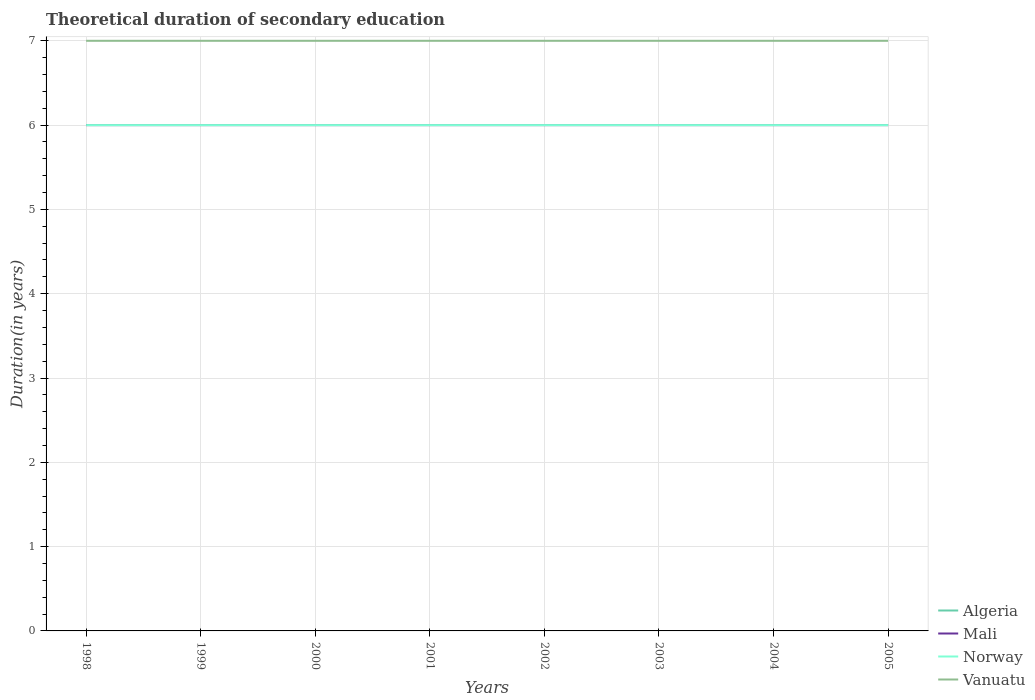Does the line corresponding to Vanuatu intersect with the line corresponding to Algeria?
Make the answer very short. No. Across all years, what is the maximum total theoretical duration of secondary education in Norway?
Provide a succinct answer. 6. In which year was the total theoretical duration of secondary education in Vanuatu maximum?
Provide a short and direct response. 1998. What is the total total theoretical duration of secondary education in Mali in the graph?
Offer a very short reply. 0. What is the difference between the highest and the second highest total theoretical duration of secondary education in Mali?
Your answer should be very brief. 0. How many years are there in the graph?
Make the answer very short. 8. Are the values on the major ticks of Y-axis written in scientific E-notation?
Your response must be concise. No. Does the graph contain grids?
Keep it short and to the point. Yes. Where does the legend appear in the graph?
Your response must be concise. Bottom right. How many legend labels are there?
Give a very brief answer. 4. How are the legend labels stacked?
Offer a very short reply. Vertical. What is the title of the graph?
Make the answer very short. Theoretical duration of secondary education. Does "Haiti" appear as one of the legend labels in the graph?
Provide a short and direct response. No. What is the label or title of the Y-axis?
Offer a terse response. Duration(in years). What is the Duration(in years) in Norway in 1998?
Offer a very short reply. 6. What is the Duration(in years) in Vanuatu in 1998?
Provide a succinct answer. 7. What is the Duration(in years) in Mali in 1999?
Your answer should be very brief. 6. What is the Duration(in years) in Norway in 1999?
Make the answer very short. 6. What is the Duration(in years) in Vanuatu in 1999?
Your answer should be very brief. 7. What is the Duration(in years) in Algeria in 2000?
Ensure brevity in your answer.  6. What is the Duration(in years) of Mali in 2000?
Your answer should be very brief. 6. What is the Duration(in years) of Vanuatu in 2000?
Provide a succinct answer. 7. What is the Duration(in years) in Mali in 2001?
Offer a very short reply. 6. What is the Duration(in years) of Norway in 2001?
Keep it short and to the point. 6. What is the Duration(in years) in Mali in 2002?
Make the answer very short. 6. What is the Duration(in years) in Algeria in 2003?
Provide a succinct answer. 6. What is the Duration(in years) in Norway in 2004?
Offer a very short reply. 6. What is the Duration(in years) in Algeria in 2005?
Keep it short and to the point. 6. What is the Duration(in years) in Vanuatu in 2005?
Your answer should be very brief. 7. Across all years, what is the maximum Duration(in years) of Vanuatu?
Provide a succinct answer. 7. Across all years, what is the minimum Duration(in years) of Norway?
Your answer should be very brief. 6. What is the total Duration(in years) in Mali in the graph?
Keep it short and to the point. 48. What is the total Duration(in years) in Norway in the graph?
Offer a very short reply. 48. What is the difference between the Duration(in years) of Algeria in 1998 and that in 1999?
Your answer should be compact. 0. What is the difference between the Duration(in years) in Mali in 1998 and that in 1999?
Provide a succinct answer. 0. What is the difference between the Duration(in years) in Norway in 1998 and that in 1999?
Provide a short and direct response. 0. What is the difference between the Duration(in years) of Vanuatu in 1998 and that in 1999?
Offer a terse response. 0. What is the difference between the Duration(in years) of Mali in 1998 and that in 2000?
Provide a succinct answer. 0. What is the difference between the Duration(in years) of Algeria in 1998 and that in 2001?
Ensure brevity in your answer.  0. What is the difference between the Duration(in years) in Mali in 1998 and that in 2002?
Offer a terse response. 0. What is the difference between the Duration(in years) of Vanuatu in 1998 and that in 2002?
Make the answer very short. 0. What is the difference between the Duration(in years) in Vanuatu in 1998 and that in 2003?
Keep it short and to the point. 0. What is the difference between the Duration(in years) in Algeria in 1998 and that in 2004?
Provide a short and direct response. 0. What is the difference between the Duration(in years) of Vanuatu in 1998 and that in 2004?
Provide a succinct answer. 0. What is the difference between the Duration(in years) of Algeria in 1998 and that in 2005?
Your response must be concise. 0. What is the difference between the Duration(in years) in Mali in 1998 and that in 2005?
Offer a very short reply. 0. What is the difference between the Duration(in years) in Vanuatu in 1998 and that in 2005?
Ensure brevity in your answer.  0. What is the difference between the Duration(in years) in Mali in 1999 and that in 2000?
Give a very brief answer. 0. What is the difference between the Duration(in years) of Norway in 1999 and that in 2000?
Your response must be concise. 0. What is the difference between the Duration(in years) of Algeria in 1999 and that in 2001?
Provide a succinct answer. 0. What is the difference between the Duration(in years) of Mali in 1999 and that in 2001?
Your answer should be compact. 0. What is the difference between the Duration(in years) in Vanuatu in 1999 and that in 2001?
Provide a succinct answer. 0. What is the difference between the Duration(in years) in Algeria in 1999 and that in 2002?
Provide a succinct answer. 0. What is the difference between the Duration(in years) in Norway in 1999 and that in 2002?
Keep it short and to the point. 0. What is the difference between the Duration(in years) of Vanuatu in 1999 and that in 2002?
Your answer should be compact. 0. What is the difference between the Duration(in years) in Algeria in 1999 and that in 2003?
Your response must be concise. 0. What is the difference between the Duration(in years) in Mali in 1999 and that in 2003?
Ensure brevity in your answer.  0. What is the difference between the Duration(in years) of Mali in 1999 and that in 2004?
Offer a very short reply. 0. What is the difference between the Duration(in years) of Norway in 1999 and that in 2004?
Provide a succinct answer. 0. What is the difference between the Duration(in years) of Vanuatu in 1999 and that in 2004?
Your answer should be compact. 0. What is the difference between the Duration(in years) in Norway in 1999 and that in 2005?
Give a very brief answer. 0. What is the difference between the Duration(in years) of Mali in 2000 and that in 2001?
Offer a terse response. 0. What is the difference between the Duration(in years) in Norway in 2000 and that in 2001?
Offer a very short reply. 0. What is the difference between the Duration(in years) of Vanuatu in 2000 and that in 2001?
Make the answer very short. 0. What is the difference between the Duration(in years) of Norway in 2000 and that in 2002?
Make the answer very short. 0. What is the difference between the Duration(in years) of Vanuatu in 2000 and that in 2002?
Offer a terse response. 0. What is the difference between the Duration(in years) of Mali in 2000 and that in 2004?
Offer a very short reply. 0. What is the difference between the Duration(in years) in Norway in 2000 and that in 2004?
Your response must be concise. 0. What is the difference between the Duration(in years) in Mali in 2001 and that in 2002?
Make the answer very short. 0. What is the difference between the Duration(in years) of Norway in 2001 and that in 2002?
Make the answer very short. 0. What is the difference between the Duration(in years) of Algeria in 2001 and that in 2004?
Your answer should be very brief. 0. What is the difference between the Duration(in years) of Mali in 2001 and that in 2004?
Make the answer very short. 0. What is the difference between the Duration(in years) in Norway in 2001 and that in 2004?
Make the answer very short. 0. What is the difference between the Duration(in years) of Norway in 2001 and that in 2005?
Your answer should be compact. 0. What is the difference between the Duration(in years) of Mali in 2002 and that in 2003?
Provide a short and direct response. 0. What is the difference between the Duration(in years) of Algeria in 2002 and that in 2004?
Offer a terse response. 0. What is the difference between the Duration(in years) of Mali in 2002 and that in 2004?
Your answer should be very brief. 0. What is the difference between the Duration(in years) of Vanuatu in 2002 and that in 2004?
Ensure brevity in your answer.  0. What is the difference between the Duration(in years) in Algeria in 2002 and that in 2005?
Your response must be concise. 0. What is the difference between the Duration(in years) in Vanuatu in 2002 and that in 2005?
Ensure brevity in your answer.  0. What is the difference between the Duration(in years) in Mali in 2003 and that in 2004?
Provide a succinct answer. 0. What is the difference between the Duration(in years) in Algeria in 2003 and that in 2005?
Provide a succinct answer. 0. What is the difference between the Duration(in years) of Mali in 2003 and that in 2005?
Your answer should be very brief. 0. What is the difference between the Duration(in years) in Vanuatu in 2003 and that in 2005?
Keep it short and to the point. 0. What is the difference between the Duration(in years) in Algeria in 2004 and that in 2005?
Your response must be concise. 0. What is the difference between the Duration(in years) in Norway in 2004 and that in 2005?
Your response must be concise. 0. What is the difference between the Duration(in years) in Vanuatu in 2004 and that in 2005?
Keep it short and to the point. 0. What is the difference between the Duration(in years) in Algeria in 1998 and the Duration(in years) in Norway in 1999?
Provide a short and direct response. 0. What is the difference between the Duration(in years) of Algeria in 1998 and the Duration(in years) of Norway in 2000?
Your response must be concise. 0. What is the difference between the Duration(in years) of Mali in 1998 and the Duration(in years) of Norway in 2000?
Offer a terse response. 0. What is the difference between the Duration(in years) of Mali in 1998 and the Duration(in years) of Vanuatu in 2000?
Make the answer very short. -1. What is the difference between the Duration(in years) of Norway in 1998 and the Duration(in years) of Vanuatu in 2000?
Give a very brief answer. -1. What is the difference between the Duration(in years) in Mali in 1998 and the Duration(in years) in Vanuatu in 2001?
Offer a very short reply. -1. What is the difference between the Duration(in years) in Algeria in 1998 and the Duration(in years) in Norway in 2002?
Keep it short and to the point. 0. What is the difference between the Duration(in years) of Mali in 1998 and the Duration(in years) of Norway in 2002?
Your response must be concise. 0. What is the difference between the Duration(in years) of Mali in 1998 and the Duration(in years) of Vanuatu in 2002?
Ensure brevity in your answer.  -1. What is the difference between the Duration(in years) in Algeria in 1998 and the Duration(in years) in Mali in 2003?
Your answer should be very brief. 0. What is the difference between the Duration(in years) of Algeria in 1998 and the Duration(in years) of Norway in 2003?
Your answer should be compact. 0. What is the difference between the Duration(in years) in Algeria in 1998 and the Duration(in years) in Vanuatu in 2003?
Offer a terse response. -1. What is the difference between the Duration(in years) of Mali in 1998 and the Duration(in years) of Vanuatu in 2003?
Offer a very short reply. -1. What is the difference between the Duration(in years) in Mali in 1998 and the Duration(in years) in Norway in 2004?
Your response must be concise. 0. What is the difference between the Duration(in years) of Mali in 1998 and the Duration(in years) of Vanuatu in 2004?
Provide a short and direct response. -1. What is the difference between the Duration(in years) of Algeria in 1998 and the Duration(in years) of Norway in 2005?
Provide a succinct answer. 0. What is the difference between the Duration(in years) of Algeria in 1998 and the Duration(in years) of Vanuatu in 2005?
Your response must be concise. -1. What is the difference between the Duration(in years) in Mali in 1998 and the Duration(in years) in Vanuatu in 2005?
Your answer should be very brief. -1. What is the difference between the Duration(in years) in Algeria in 1999 and the Duration(in years) in Norway in 2000?
Keep it short and to the point. 0. What is the difference between the Duration(in years) in Mali in 1999 and the Duration(in years) in Norway in 2000?
Your response must be concise. 0. What is the difference between the Duration(in years) in Norway in 1999 and the Duration(in years) in Vanuatu in 2000?
Ensure brevity in your answer.  -1. What is the difference between the Duration(in years) in Algeria in 1999 and the Duration(in years) in Vanuatu in 2001?
Your response must be concise. -1. What is the difference between the Duration(in years) of Mali in 1999 and the Duration(in years) of Norway in 2001?
Offer a very short reply. 0. What is the difference between the Duration(in years) of Norway in 1999 and the Duration(in years) of Vanuatu in 2001?
Make the answer very short. -1. What is the difference between the Duration(in years) in Algeria in 1999 and the Duration(in years) in Norway in 2002?
Ensure brevity in your answer.  0. What is the difference between the Duration(in years) of Mali in 1999 and the Duration(in years) of Norway in 2002?
Ensure brevity in your answer.  0. What is the difference between the Duration(in years) in Mali in 1999 and the Duration(in years) in Vanuatu in 2002?
Keep it short and to the point. -1. What is the difference between the Duration(in years) of Algeria in 1999 and the Duration(in years) of Mali in 2003?
Give a very brief answer. 0. What is the difference between the Duration(in years) in Algeria in 1999 and the Duration(in years) in Norway in 2003?
Ensure brevity in your answer.  0. What is the difference between the Duration(in years) of Mali in 1999 and the Duration(in years) of Norway in 2003?
Provide a short and direct response. 0. What is the difference between the Duration(in years) in Mali in 1999 and the Duration(in years) in Vanuatu in 2003?
Provide a short and direct response. -1. What is the difference between the Duration(in years) in Norway in 1999 and the Duration(in years) in Vanuatu in 2003?
Offer a terse response. -1. What is the difference between the Duration(in years) in Algeria in 1999 and the Duration(in years) in Mali in 2004?
Make the answer very short. 0. What is the difference between the Duration(in years) in Algeria in 1999 and the Duration(in years) in Vanuatu in 2004?
Offer a very short reply. -1. What is the difference between the Duration(in years) in Mali in 1999 and the Duration(in years) in Norway in 2004?
Offer a terse response. 0. What is the difference between the Duration(in years) of Mali in 1999 and the Duration(in years) of Vanuatu in 2004?
Provide a succinct answer. -1. What is the difference between the Duration(in years) in Algeria in 1999 and the Duration(in years) in Mali in 2005?
Your answer should be very brief. 0. What is the difference between the Duration(in years) of Algeria in 2000 and the Duration(in years) of Mali in 2002?
Keep it short and to the point. 0. What is the difference between the Duration(in years) of Algeria in 2000 and the Duration(in years) of Norway in 2002?
Keep it short and to the point. 0. What is the difference between the Duration(in years) in Mali in 2000 and the Duration(in years) in Vanuatu in 2002?
Ensure brevity in your answer.  -1. What is the difference between the Duration(in years) of Norway in 2000 and the Duration(in years) of Vanuatu in 2002?
Provide a short and direct response. -1. What is the difference between the Duration(in years) in Algeria in 2000 and the Duration(in years) in Vanuatu in 2003?
Give a very brief answer. -1. What is the difference between the Duration(in years) of Mali in 2000 and the Duration(in years) of Norway in 2003?
Your answer should be compact. 0. What is the difference between the Duration(in years) in Algeria in 2000 and the Duration(in years) in Mali in 2004?
Provide a succinct answer. 0. What is the difference between the Duration(in years) in Algeria in 2000 and the Duration(in years) in Vanuatu in 2004?
Your answer should be compact. -1. What is the difference between the Duration(in years) in Mali in 2000 and the Duration(in years) in Norway in 2004?
Ensure brevity in your answer.  0. What is the difference between the Duration(in years) in Norway in 2000 and the Duration(in years) in Vanuatu in 2004?
Your answer should be very brief. -1. What is the difference between the Duration(in years) of Algeria in 2000 and the Duration(in years) of Mali in 2005?
Provide a succinct answer. 0. What is the difference between the Duration(in years) in Algeria in 2000 and the Duration(in years) in Vanuatu in 2005?
Provide a succinct answer. -1. What is the difference between the Duration(in years) of Mali in 2000 and the Duration(in years) of Vanuatu in 2005?
Make the answer very short. -1. What is the difference between the Duration(in years) in Norway in 2000 and the Duration(in years) in Vanuatu in 2005?
Your answer should be compact. -1. What is the difference between the Duration(in years) of Algeria in 2001 and the Duration(in years) of Vanuatu in 2002?
Offer a very short reply. -1. What is the difference between the Duration(in years) in Mali in 2001 and the Duration(in years) in Norway in 2002?
Provide a short and direct response. 0. What is the difference between the Duration(in years) in Algeria in 2001 and the Duration(in years) in Norway in 2003?
Your answer should be very brief. 0. What is the difference between the Duration(in years) of Algeria in 2001 and the Duration(in years) of Vanuatu in 2003?
Offer a terse response. -1. What is the difference between the Duration(in years) in Mali in 2001 and the Duration(in years) in Norway in 2003?
Your answer should be very brief. 0. What is the difference between the Duration(in years) of Mali in 2001 and the Duration(in years) of Vanuatu in 2003?
Give a very brief answer. -1. What is the difference between the Duration(in years) of Algeria in 2001 and the Duration(in years) of Mali in 2004?
Make the answer very short. 0. What is the difference between the Duration(in years) of Algeria in 2001 and the Duration(in years) of Vanuatu in 2004?
Keep it short and to the point. -1. What is the difference between the Duration(in years) of Mali in 2001 and the Duration(in years) of Norway in 2004?
Your response must be concise. 0. What is the difference between the Duration(in years) in Algeria in 2001 and the Duration(in years) in Mali in 2005?
Ensure brevity in your answer.  0. What is the difference between the Duration(in years) in Algeria in 2001 and the Duration(in years) in Norway in 2005?
Make the answer very short. 0. What is the difference between the Duration(in years) in Algeria in 2001 and the Duration(in years) in Vanuatu in 2005?
Offer a terse response. -1. What is the difference between the Duration(in years) in Mali in 2001 and the Duration(in years) in Norway in 2005?
Keep it short and to the point. 0. What is the difference between the Duration(in years) in Norway in 2001 and the Duration(in years) in Vanuatu in 2005?
Provide a succinct answer. -1. What is the difference between the Duration(in years) of Algeria in 2002 and the Duration(in years) of Mali in 2003?
Offer a very short reply. 0. What is the difference between the Duration(in years) of Mali in 2002 and the Duration(in years) of Vanuatu in 2003?
Your response must be concise. -1. What is the difference between the Duration(in years) in Norway in 2002 and the Duration(in years) in Vanuatu in 2003?
Make the answer very short. -1. What is the difference between the Duration(in years) of Algeria in 2002 and the Duration(in years) of Mali in 2004?
Keep it short and to the point. 0. What is the difference between the Duration(in years) in Algeria in 2002 and the Duration(in years) in Norway in 2004?
Make the answer very short. 0. What is the difference between the Duration(in years) of Mali in 2002 and the Duration(in years) of Norway in 2004?
Provide a short and direct response. 0. What is the difference between the Duration(in years) in Algeria in 2002 and the Duration(in years) in Norway in 2005?
Make the answer very short. 0. What is the difference between the Duration(in years) of Mali in 2002 and the Duration(in years) of Norway in 2005?
Provide a short and direct response. 0. What is the difference between the Duration(in years) in Norway in 2002 and the Duration(in years) in Vanuatu in 2005?
Ensure brevity in your answer.  -1. What is the difference between the Duration(in years) in Algeria in 2003 and the Duration(in years) in Norway in 2004?
Your response must be concise. 0. What is the difference between the Duration(in years) of Algeria in 2003 and the Duration(in years) of Vanuatu in 2004?
Keep it short and to the point. -1. What is the difference between the Duration(in years) in Mali in 2003 and the Duration(in years) in Norway in 2004?
Give a very brief answer. 0. What is the difference between the Duration(in years) of Norway in 2003 and the Duration(in years) of Vanuatu in 2004?
Keep it short and to the point. -1. What is the difference between the Duration(in years) of Algeria in 2003 and the Duration(in years) of Norway in 2005?
Offer a terse response. 0. What is the difference between the Duration(in years) of Mali in 2003 and the Duration(in years) of Vanuatu in 2005?
Give a very brief answer. -1. What is the difference between the Duration(in years) of Algeria in 2004 and the Duration(in years) of Mali in 2005?
Offer a terse response. 0. What is the difference between the Duration(in years) in Mali in 2004 and the Duration(in years) in Norway in 2005?
Provide a short and direct response. 0. What is the difference between the Duration(in years) in Norway in 2004 and the Duration(in years) in Vanuatu in 2005?
Provide a succinct answer. -1. What is the average Duration(in years) of Algeria per year?
Give a very brief answer. 6. In the year 1998, what is the difference between the Duration(in years) in Algeria and Duration(in years) in Norway?
Provide a short and direct response. 0. In the year 1998, what is the difference between the Duration(in years) in Algeria and Duration(in years) in Vanuatu?
Provide a succinct answer. -1. In the year 1999, what is the difference between the Duration(in years) of Algeria and Duration(in years) of Vanuatu?
Ensure brevity in your answer.  -1. In the year 1999, what is the difference between the Duration(in years) of Mali and Duration(in years) of Norway?
Ensure brevity in your answer.  0. In the year 1999, what is the difference between the Duration(in years) of Mali and Duration(in years) of Vanuatu?
Offer a terse response. -1. In the year 1999, what is the difference between the Duration(in years) in Norway and Duration(in years) in Vanuatu?
Keep it short and to the point. -1. In the year 2000, what is the difference between the Duration(in years) in Algeria and Duration(in years) in Vanuatu?
Provide a succinct answer. -1. In the year 2000, what is the difference between the Duration(in years) in Mali and Duration(in years) in Vanuatu?
Give a very brief answer. -1. In the year 2001, what is the difference between the Duration(in years) of Algeria and Duration(in years) of Mali?
Offer a very short reply. 0. In the year 2001, what is the difference between the Duration(in years) of Algeria and Duration(in years) of Norway?
Keep it short and to the point. 0. In the year 2001, what is the difference between the Duration(in years) in Algeria and Duration(in years) in Vanuatu?
Your answer should be compact. -1. In the year 2001, what is the difference between the Duration(in years) in Mali and Duration(in years) in Norway?
Provide a short and direct response. 0. In the year 2001, what is the difference between the Duration(in years) in Mali and Duration(in years) in Vanuatu?
Your answer should be compact. -1. In the year 2001, what is the difference between the Duration(in years) in Norway and Duration(in years) in Vanuatu?
Offer a terse response. -1. In the year 2002, what is the difference between the Duration(in years) of Algeria and Duration(in years) of Vanuatu?
Make the answer very short. -1. In the year 2003, what is the difference between the Duration(in years) of Algeria and Duration(in years) of Mali?
Keep it short and to the point. 0. In the year 2003, what is the difference between the Duration(in years) in Algeria and Duration(in years) in Norway?
Ensure brevity in your answer.  0. In the year 2003, what is the difference between the Duration(in years) in Algeria and Duration(in years) in Vanuatu?
Your answer should be very brief. -1. In the year 2003, what is the difference between the Duration(in years) in Mali and Duration(in years) in Vanuatu?
Offer a very short reply. -1. In the year 2003, what is the difference between the Duration(in years) in Norway and Duration(in years) in Vanuatu?
Make the answer very short. -1. In the year 2004, what is the difference between the Duration(in years) of Algeria and Duration(in years) of Mali?
Your response must be concise. 0. In the year 2004, what is the difference between the Duration(in years) of Algeria and Duration(in years) of Norway?
Offer a terse response. 0. In the year 2004, what is the difference between the Duration(in years) of Mali and Duration(in years) of Vanuatu?
Offer a very short reply. -1. In the year 2004, what is the difference between the Duration(in years) in Norway and Duration(in years) in Vanuatu?
Offer a terse response. -1. In the year 2005, what is the difference between the Duration(in years) in Mali and Duration(in years) in Norway?
Your response must be concise. 0. What is the ratio of the Duration(in years) in Mali in 1998 to that in 2000?
Your answer should be very brief. 1. What is the ratio of the Duration(in years) in Vanuatu in 1998 to that in 2000?
Give a very brief answer. 1. What is the ratio of the Duration(in years) in Algeria in 1998 to that in 2001?
Make the answer very short. 1. What is the ratio of the Duration(in years) in Norway in 1998 to that in 2001?
Offer a terse response. 1. What is the ratio of the Duration(in years) of Algeria in 1998 to that in 2002?
Provide a succinct answer. 1. What is the ratio of the Duration(in years) in Mali in 1998 to that in 2002?
Ensure brevity in your answer.  1. What is the ratio of the Duration(in years) of Norway in 1998 to that in 2002?
Your response must be concise. 1. What is the ratio of the Duration(in years) of Vanuatu in 1998 to that in 2003?
Your answer should be compact. 1. What is the ratio of the Duration(in years) in Norway in 1998 to that in 2004?
Your response must be concise. 1. What is the ratio of the Duration(in years) of Mali in 1999 to that in 2000?
Your answer should be very brief. 1. What is the ratio of the Duration(in years) of Vanuatu in 1999 to that in 2000?
Keep it short and to the point. 1. What is the ratio of the Duration(in years) in Algeria in 1999 to that in 2001?
Provide a succinct answer. 1. What is the ratio of the Duration(in years) of Mali in 1999 to that in 2001?
Provide a succinct answer. 1. What is the ratio of the Duration(in years) of Norway in 1999 to that in 2003?
Keep it short and to the point. 1. What is the ratio of the Duration(in years) of Norway in 1999 to that in 2004?
Your answer should be compact. 1. What is the ratio of the Duration(in years) in Mali in 1999 to that in 2005?
Keep it short and to the point. 1. What is the ratio of the Duration(in years) of Norway in 1999 to that in 2005?
Ensure brevity in your answer.  1. What is the ratio of the Duration(in years) of Vanuatu in 1999 to that in 2005?
Provide a short and direct response. 1. What is the ratio of the Duration(in years) in Algeria in 2000 to that in 2001?
Provide a short and direct response. 1. What is the ratio of the Duration(in years) of Norway in 2000 to that in 2001?
Your response must be concise. 1. What is the ratio of the Duration(in years) in Vanuatu in 2000 to that in 2001?
Provide a succinct answer. 1. What is the ratio of the Duration(in years) of Mali in 2000 to that in 2002?
Your answer should be compact. 1. What is the ratio of the Duration(in years) in Norway in 2000 to that in 2002?
Keep it short and to the point. 1. What is the ratio of the Duration(in years) in Mali in 2000 to that in 2004?
Your response must be concise. 1. What is the ratio of the Duration(in years) in Vanuatu in 2000 to that in 2004?
Your response must be concise. 1. What is the ratio of the Duration(in years) in Algeria in 2000 to that in 2005?
Keep it short and to the point. 1. What is the ratio of the Duration(in years) in Mali in 2000 to that in 2005?
Your answer should be very brief. 1. What is the ratio of the Duration(in years) of Vanuatu in 2000 to that in 2005?
Provide a short and direct response. 1. What is the ratio of the Duration(in years) of Algeria in 2001 to that in 2002?
Offer a terse response. 1. What is the ratio of the Duration(in years) in Mali in 2001 to that in 2004?
Your response must be concise. 1. What is the ratio of the Duration(in years) of Norway in 2001 to that in 2004?
Ensure brevity in your answer.  1. What is the ratio of the Duration(in years) in Algeria in 2001 to that in 2005?
Offer a terse response. 1. What is the ratio of the Duration(in years) in Vanuatu in 2001 to that in 2005?
Offer a terse response. 1. What is the ratio of the Duration(in years) in Algeria in 2002 to that in 2003?
Your response must be concise. 1. What is the ratio of the Duration(in years) in Mali in 2002 to that in 2003?
Offer a very short reply. 1. What is the ratio of the Duration(in years) in Vanuatu in 2002 to that in 2003?
Your answer should be very brief. 1. What is the ratio of the Duration(in years) in Algeria in 2002 to that in 2004?
Your answer should be very brief. 1. What is the ratio of the Duration(in years) of Norway in 2002 to that in 2004?
Your answer should be very brief. 1. What is the ratio of the Duration(in years) of Vanuatu in 2002 to that in 2004?
Your answer should be compact. 1. What is the ratio of the Duration(in years) in Algeria in 2002 to that in 2005?
Provide a short and direct response. 1. What is the ratio of the Duration(in years) of Mali in 2002 to that in 2005?
Your answer should be compact. 1. What is the ratio of the Duration(in years) of Algeria in 2003 to that in 2004?
Keep it short and to the point. 1. What is the ratio of the Duration(in years) in Mali in 2003 to that in 2004?
Make the answer very short. 1. What is the ratio of the Duration(in years) of Vanuatu in 2003 to that in 2004?
Keep it short and to the point. 1. What is the ratio of the Duration(in years) of Algeria in 2003 to that in 2005?
Your answer should be very brief. 1. What is the ratio of the Duration(in years) of Vanuatu in 2003 to that in 2005?
Your response must be concise. 1. What is the ratio of the Duration(in years) in Vanuatu in 2004 to that in 2005?
Give a very brief answer. 1. What is the difference between the highest and the second highest Duration(in years) in Algeria?
Your answer should be very brief. 0. What is the difference between the highest and the second highest Duration(in years) in Norway?
Your answer should be compact. 0. What is the difference between the highest and the lowest Duration(in years) of Algeria?
Provide a succinct answer. 0. What is the difference between the highest and the lowest Duration(in years) of Mali?
Provide a short and direct response. 0. 